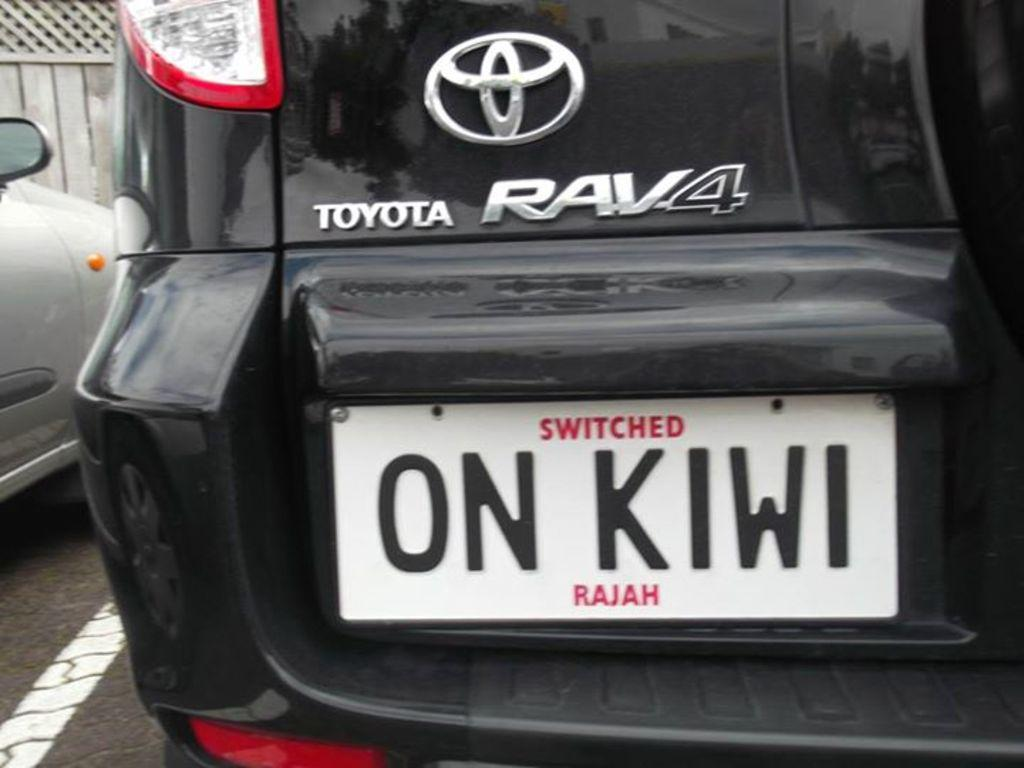Provide a one-sentence caption for the provided image. A black Toyota RAV4 with the license plate ON KIWI is parked. 